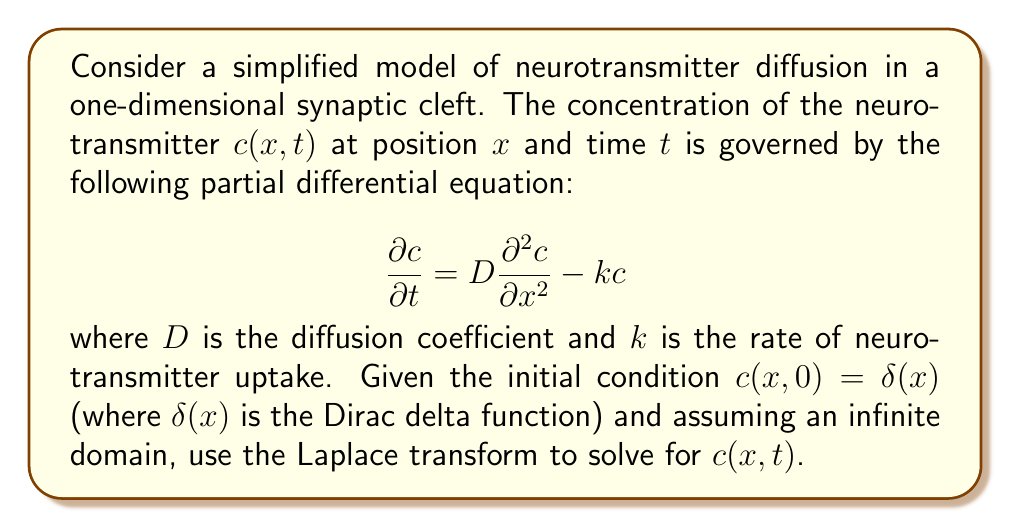Give your solution to this math problem. To solve this problem, we'll use the Laplace transform method:

1) First, let's take the Laplace transform of the PDE with respect to $t$:

   $$\mathcal{L}\left\{\frac{\partial c}{\partial t}\right\} = D\mathcal{L}\left\{\frac{\partial^2 c}{\partial x^2}\right\} - k\mathcal{L}\{c\}$$

2) Using the properties of the Laplace transform:

   $$sC(x,s) - c(x,0) = D\frac{d^2C(x,s)}{dx^2} - kC(x,s)$$

   where $C(x,s)$ is the Laplace transform of $c(x,t)$.

3) Substituting the initial condition $c(x,0) = \delta(x)$:

   $$sC(x,s) - \delta(x) = D\frac{d^2C(x,s)}{dx^2} - kC(x,s)$$

4) Rearranging:

   $$D\frac{d^2C(x,s)}{dx^2} - (s+k)C(x,s) = -\delta(x)$$

5) This is an ordinary differential equation in $x$. Its general solution is:

   $$C(x,s) = A\exp\left(-\sqrt{\frac{s+k}{D}}|x|\right)$$

   where $A$ is a constant to be determined.

6) To find $A$, we integrate both sides of the equation in step 4 from $-\epsilon$ to $\epsilon$ and take the limit as $\epsilon \to 0$:

   $$\lim_{\epsilon \to 0} \left[D\frac{dC(x,s)}{dx}\right]_{-\epsilon}^{\epsilon} = -1$$

7) Evaluating this:

   $$-2DA\sqrt{\frac{s+k}{D}} = -1$$

   $$A = \frac{1}{2D\sqrt{\frac{s+k}{D}}} = \frac{1}{2\sqrt{D(s+k)}}$$

8) Therefore, the Laplace transform of the solution is:

   $$C(x,s) = \frac{1}{2\sqrt{D(s+k)}}\exp\left(-\sqrt{\frac{s+k}{D}}|x|\right)$$

9) To find $c(x,t)$, we need to take the inverse Laplace transform. This can be recognized as:

   $$c(x,t) = \mathcal{L}^{-1}\{C(x,s)\} = \frac{1}{2\sqrt{\pi Dt}}\exp\left(-\frac{x^2}{4Dt} - kt\right)$$

This is the final solution for the concentration of neurotransmitter as a function of position and time.
Answer: $$c(x,t) = \frac{1}{2\sqrt{\pi Dt}}\exp\left(-\frac{x^2}{4Dt} - kt\right)$$ 